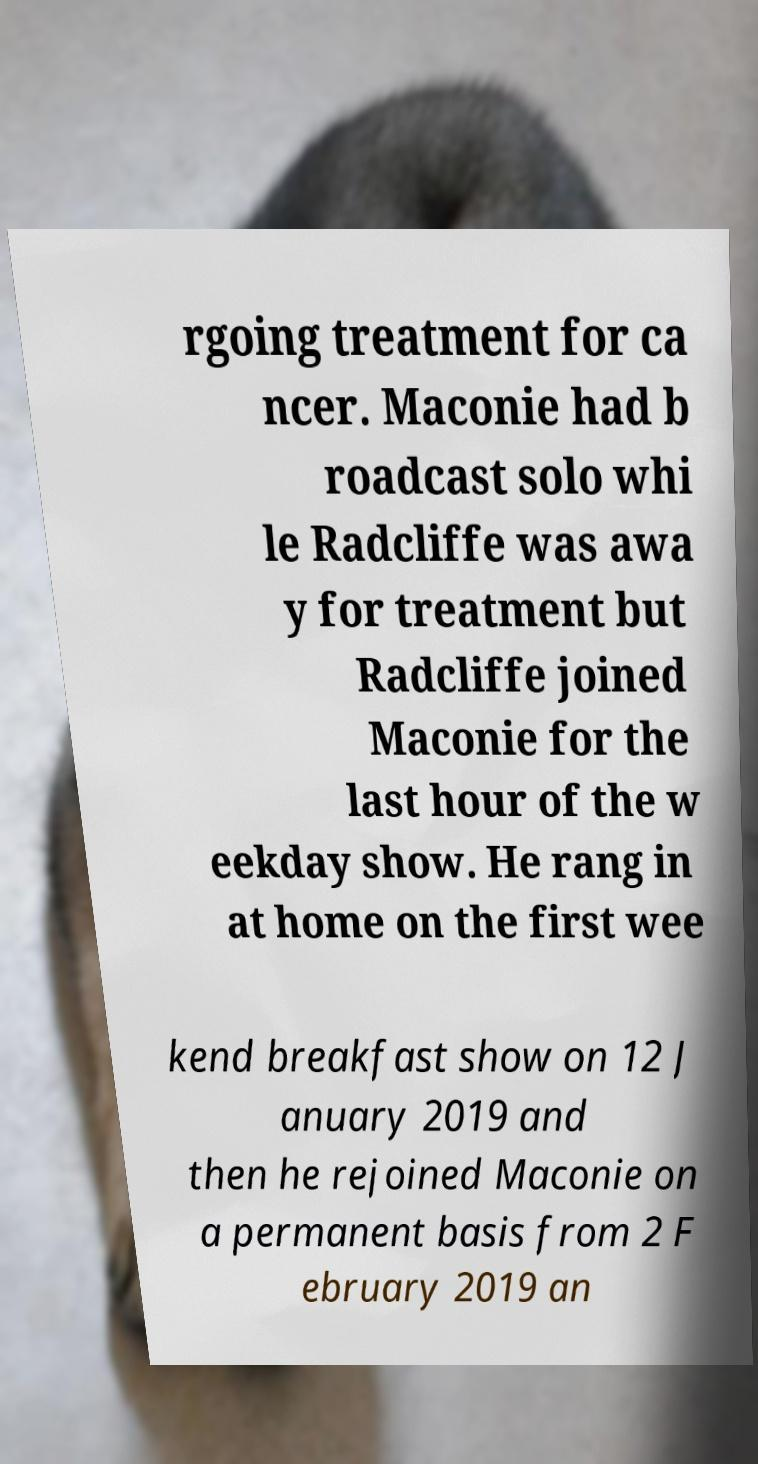What messages or text are displayed in this image? I need them in a readable, typed format. rgoing treatment for ca ncer. Maconie had b roadcast solo whi le Radcliffe was awa y for treatment but Radcliffe joined Maconie for the last hour of the w eekday show. He rang in at home on the first wee kend breakfast show on 12 J anuary 2019 and then he rejoined Maconie on a permanent basis from 2 F ebruary 2019 an 